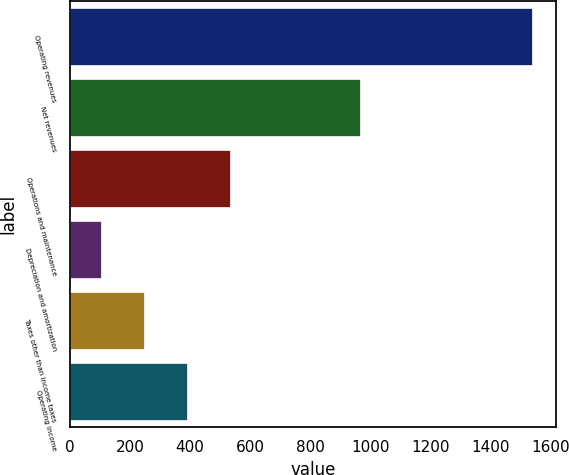Convert chart to OTSL. <chart><loc_0><loc_0><loc_500><loc_500><bar_chart><fcel>Operating revenues<fcel>Net revenues<fcel>Operations and maintenance<fcel>Depreciation and amortization<fcel>Taxes other than income taxes<fcel>Operating income<nl><fcel>1541<fcel>967<fcel>533.7<fcel>102<fcel>245.9<fcel>389.8<nl></chart> 